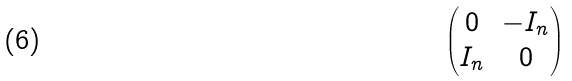Convert formula to latex. <formula><loc_0><loc_0><loc_500><loc_500>\begin{pmatrix} 0 & - I _ { n } \\ I _ { n } & 0 \end{pmatrix}</formula> 